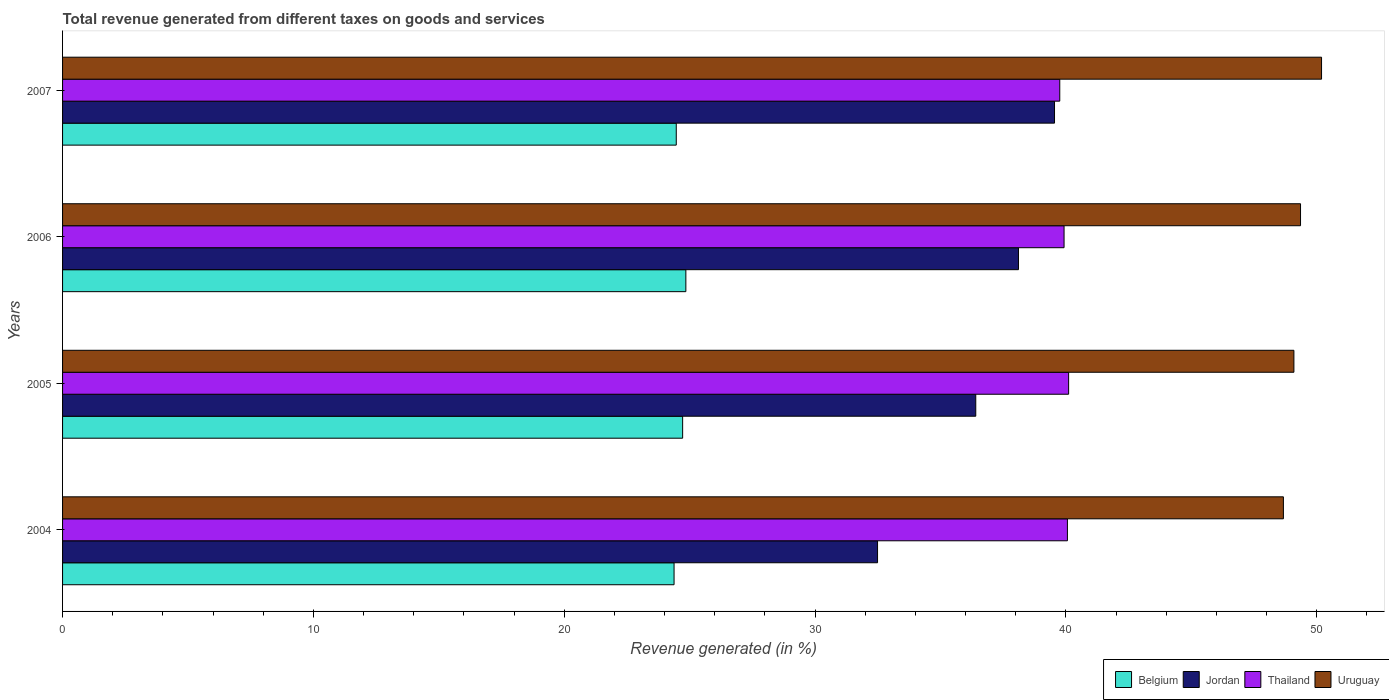How many different coloured bars are there?
Keep it short and to the point. 4. What is the label of the 2nd group of bars from the top?
Your answer should be compact. 2006. What is the total revenue generated in Uruguay in 2005?
Offer a terse response. 49.09. Across all years, what is the maximum total revenue generated in Belgium?
Provide a succinct answer. 24.85. Across all years, what is the minimum total revenue generated in Belgium?
Make the answer very short. 24.38. What is the total total revenue generated in Jordan in the graph?
Provide a succinct answer. 146.55. What is the difference between the total revenue generated in Uruguay in 2005 and that in 2006?
Your answer should be compact. -0.26. What is the difference between the total revenue generated in Uruguay in 2006 and the total revenue generated in Jordan in 2005?
Offer a very short reply. 12.95. What is the average total revenue generated in Belgium per year?
Your answer should be very brief. 24.6. In the year 2006, what is the difference between the total revenue generated in Belgium and total revenue generated in Jordan?
Give a very brief answer. -13.26. What is the ratio of the total revenue generated in Thailand in 2004 to that in 2006?
Your answer should be compact. 1. What is the difference between the highest and the second highest total revenue generated in Thailand?
Offer a very short reply. 0.05. What is the difference between the highest and the lowest total revenue generated in Thailand?
Offer a very short reply. 0.35. Is the sum of the total revenue generated in Thailand in 2006 and 2007 greater than the maximum total revenue generated in Belgium across all years?
Make the answer very short. Yes. Is it the case that in every year, the sum of the total revenue generated in Uruguay and total revenue generated in Belgium is greater than the sum of total revenue generated in Thailand and total revenue generated in Jordan?
Your response must be concise. Yes. What does the 1st bar from the top in 2004 represents?
Your answer should be very brief. Uruguay. What does the 3rd bar from the bottom in 2007 represents?
Give a very brief answer. Thailand. Are all the bars in the graph horizontal?
Provide a succinct answer. Yes. What is the difference between two consecutive major ticks on the X-axis?
Your answer should be compact. 10. Does the graph contain grids?
Provide a succinct answer. No. How many legend labels are there?
Your answer should be very brief. 4. How are the legend labels stacked?
Ensure brevity in your answer.  Horizontal. What is the title of the graph?
Offer a very short reply. Total revenue generated from different taxes on goods and services. What is the label or title of the X-axis?
Your response must be concise. Revenue generated (in %). What is the label or title of the Y-axis?
Offer a very short reply. Years. What is the Revenue generated (in %) of Belgium in 2004?
Offer a very short reply. 24.38. What is the Revenue generated (in %) in Jordan in 2004?
Ensure brevity in your answer.  32.49. What is the Revenue generated (in %) in Thailand in 2004?
Ensure brevity in your answer.  40.06. What is the Revenue generated (in %) in Uruguay in 2004?
Your response must be concise. 48.67. What is the Revenue generated (in %) in Belgium in 2005?
Keep it short and to the point. 24.72. What is the Revenue generated (in %) of Jordan in 2005?
Offer a terse response. 36.41. What is the Revenue generated (in %) in Thailand in 2005?
Offer a terse response. 40.11. What is the Revenue generated (in %) in Uruguay in 2005?
Provide a short and direct response. 49.09. What is the Revenue generated (in %) of Belgium in 2006?
Give a very brief answer. 24.85. What is the Revenue generated (in %) of Jordan in 2006?
Your answer should be compact. 38.11. What is the Revenue generated (in %) of Thailand in 2006?
Keep it short and to the point. 39.93. What is the Revenue generated (in %) in Uruguay in 2006?
Ensure brevity in your answer.  49.35. What is the Revenue generated (in %) of Belgium in 2007?
Your response must be concise. 24.47. What is the Revenue generated (in %) in Jordan in 2007?
Your answer should be compact. 39.55. What is the Revenue generated (in %) of Thailand in 2007?
Keep it short and to the point. 39.76. What is the Revenue generated (in %) in Uruguay in 2007?
Give a very brief answer. 50.19. Across all years, what is the maximum Revenue generated (in %) in Belgium?
Your answer should be very brief. 24.85. Across all years, what is the maximum Revenue generated (in %) in Jordan?
Offer a terse response. 39.55. Across all years, what is the maximum Revenue generated (in %) of Thailand?
Offer a very short reply. 40.11. Across all years, what is the maximum Revenue generated (in %) of Uruguay?
Ensure brevity in your answer.  50.19. Across all years, what is the minimum Revenue generated (in %) in Belgium?
Offer a terse response. 24.38. Across all years, what is the minimum Revenue generated (in %) in Jordan?
Offer a terse response. 32.49. Across all years, what is the minimum Revenue generated (in %) in Thailand?
Offer a very short reply. 39.76. Across all years, what is the minimum Revenue generated (in %) in Uruguay?
Your answer should be compact. 48.67. What is the total Revenue generated (in %) in Belgium in the graph?
Your answer should be compact. 98.42. What is the total Revenue generated (in %) of Jordan in the graph?
Your response must be concise. 146.55. What is the total Revenue generated (in %) of Thailand in the graph?
Provide a short and direct response. 159.85. What is the total Revenue generated (in %) of Uruguay in the graph?
Make the answer very short. 197.31. What is the difference between the Revenue generated (in %) of Belgium in 2004 and that in 2005?
Your answer should be very brief. -0.34. What is the difference between the Revenue generated (in %) of Jordan in 2004 and that in 2005?
Your answer should be compact. -3.92. What is the difference between the Revenue generated (in %) of Thailand in 2004 and that in 2005?
Keep it short and to the point. -0.05. What is the difference between the Revenue generated (in %) in Uruguay in 2004 and that in 2005?
Offer a terse response. -0.42. What is the difference between the Revenue generated (in %) of Belgium in 2004 and that in 2006?
Offer a terse response. -0.47. What is the difference between the Revenue generated (in %) of Jordan in 2004 and that in 2006?
Your answer should be very brief. -5.62. What is the difference between the Revenue generated (in %) of Thailand in 2004 and that in 2006?
Your answer should be compact. 0.13. What is the difference between the Revenue generated (in %) of Uruguay in 2004 and that in 2006?
Give a very brief answer. -0.68. What is the difference between the Revenue generated (in %) of Belgium in 2004 and that in 2007?
Give a very brief answer. -0.09. What is the difference between the Revenue generated (in %) in Jordan in 2004 and that in 2007?
Offer a terse response. -7.06. What is the difference between the Revenue generated (in %) of Thailand in 2004 and that in 2007?
Your answer should be very brief. 0.3. What is the difference between the Revenue generated (in %) of Uruguay in 2004 and that in 2007?
Make the answer very short. -1.52. What is the difference between the Revenue generated (in %) of Belgium in 2005 and that in 2006?
Provide a short and direct response. -0.13. What is the difference between the Revenue generated (in %) in Jordan in 2005 and that in 2006?
Provide a succinct answer. -1.7. What is the difference between the Revenue generated (in %) in Thailand in 2005 and that in 2006?
Ensure brevity in your answer.  0.18. What is the difference between the Revenue generated (in %) of Uruguay in 2005 and that in 2006?
Offer a terse response. -0.26. What is the difference between the Revenue generated (in %) in Belgium in 2005 and that in 2007?
Offer a very short reply. 0.25. What is the difference between the Revenue generated (in %) of Jordan in 2005 and that in 2007?
Your response must be concise. -3.14. What is the difference between the Revenue generated (in %) in Thailand in 2005 and that in 2007?
Your answer should be very brief. 0.35. What is the difference between the Revenue generated (in %) in Uruguay in 2005 and that in 2007?
Ensure brevity in your answer.  -1.1. What is the difference between the Revenue generated (in %) in Belgium in 2006 and that in 2007?
Your answer should be very brief. 0.38. What is the difference between the Revenue generated (in %) of Jordan in 2006 and that in 2007?
Offer a very short reply. -1.44. What is the difference between the Revenue generated (in %) in Thailand in 2006 and that in 2007?
Your answer should be compact. 0.17. What is the difference between the Revenue generated (in %) in Uruguay in 2006 and that in 2007?
Give a very brief answer. -0.84. What is the difference between the Revenue generated (in %) in Belgium in 2004 and the Revenue generated (in %) in Jordan in 2005?
Ensure brevity in your answer.  -12.03. What is the difference between the Revenue generated (in %) of Belgium in 2004 and the Revenue generated (in %) of Thailand in 2005?
Offer a very short reply. -15.73. What is the difference between the Revenue generated (in %) of Belgium in 2004 and the Revenue generated (in %) of Uruguay in 2005?
Ensure brevity in your answer.  -24.71. What is the difference between the Revenue generated (in %) in Jordan in 2004 and the Revenue generated (in %) in Thailand in 2005?
Provide a succinct answer. -7.62. What is the difference between the Revenue generated (in %) of Jordan in 2004 and the Revenue generated (in %) of Uruguay in 2005?
Your answer should be very brief. -16.6. What is the difference between the Revenue generated (in %) of Thailand in 2004 and the Revenue generated (in %) of Uruguay in 2005?
Provide a short and direct response. -9.03. What is the difference between the Revenue generated (in %) in Belgium in 2004 and the Revenue generated (in %) in Jordan in 2006?
Ensure brevity in your answer.  -13.73. What is the difference between the Revenue generated (in %) in Belgium in 2004 and the Revenue generated (in %) in Thailand in 2006?
Give a very brief answer. -15.55. What is the difference between the Revenue generated (in %) of Belgium in 2004 and the Revenue generated (in %) of Uruguay in 2006?
Provide a succinct answer. -24.98. What is the difference between the Revenue generated (in %) of Jordan in 2004 and the Revenue generated (in %) of Thailand in 2006?
Keep it short and to the point. -7.44. What is the difference between the Revenue generated (in %) of Jordan in 2004 and the Revenue generated (in %) of Uruguay in 2006?
Keep it short and to the point. -16.86. What is the difference between the Revenue generated (in %) of Thailand in 2004 and the Revenue generated (in %) of Uruguay in 2006?
Offer a terse response. -9.29. What is the difference between the Revenue generated (in %) in Belgium in 2004 and the Revenue generated (in %) in Jordan in 2007?
Give a very brief answer. -15.17. What is the difference between the Revenue generated (in %) in Belgium in 2004 and the Revenue generated (in %) in Thailand in 2007?
Provide a succinct answer. -15.38. What is the difference between the Revenue generated (in %) of Belgium in 2004 and the Revenue generated (in %) of Uruguay in 2007?
Provide a short and direct response. -25.81. What is the difference between the Revenue generated (in %) of Jordan in 2004 and the Revenue generated (in %) of Thailand in 2007?
Offer a terse response. -7.26. What is the difference between the Revenue generated (in %) in Jordan in 2004 and the Revenue generated (in %) in Uruguay in 2007?
Offer a terse response. -17.7. What is the difference between the Revenue generated (in %) of Thailand in 2004 and the Revenue generated (in %) of Uruguay in 2007?
Offer a very short reply. -10.13. What is the difference between the Revenue generated (in %) in Belgium in 2005 and the Revenue generated (in %) in Jordan in 2006?
Your answer should be very brief. -13.39. What is the difference between the Revenue generated (in %) in Belgium in 2005 and the Revenue generated (in %) in Thailand in 2006?
Your answer should be compact. -15.21. What is the difference between the Revenue generated (in %) of Belgium in 2005 and the Revenue generated (in %) of Uruguay in 2006?
Offer a terse response. -24.63. What is the difference between the Revenue generated (in %) in Jordan in 2005 and the Revenue generated (in %) in Thailand in 2006?
Provide a short and direct response. -3.52. What is the difference between the Revenue generated (in %) of Jordan in 2005 and the Revenue generated (in %) of Uruguay in 2006?
Your answer should be compact. -12.95. What is the difference between the Revenue generated (in %) in Thailand in 2005 and the Revenue generated (in %) in Uruguay in 2006?
Offer a terse response. -9.25. What is the difference between the Revenue generated (in %) of Belgium in 2005 and the Revenue generated (in %) of Jordan in 2007?
Make the answer very short. -14.83. What is the difference between the Revenue generated (in %) in Belgium in 2005 and the Revenue generated (in %) in Thailand in 2007?
Offer a terse response. -15.04. What is the difference between the Revenue generated (in %) of Belgium in 2005 and the Revenue generated (in %) of Uruguay in 2007?
Your response must be concise. -25.47. What is the difference between the Revenue generated (in %) in Jordan in 2005 and the Revenue generated (in %) in Thailand in 2007?
Keep it short and to the point. -3.35. What is the difference between the Revenue generated (in %) in Jordan in 2005 and the Revenue generated (in %) in Uruguay in 2007?
Your response must be concise. -13.79. What is the difference between the Revenue generated (in %) of Thailand in 2005 and the Revenue generated (in %) of Uruguay in 2007?
Your answer should be compact. -10.08. What is the difference between the Revenue generated (in %) of Belgium in 2006 and the Revenue generated (in %) of Jordan in 2007?
Give a very brief answer. -14.7. What is the difference between the Revenue generated (in %) in Belgium in 2006 and the Revenue generated (in %) in Thailand in 2007?
Provide a short and direct response. -14.91. What is the difference between the Revenue generated (in %) of Belgium in 2006 and the Revenue generated (in %) of Uruguay in 2007?
Offer a terse response. -25.34. What is the difference between the Revenue generated (in %) in Jordan in 2006 and the Revenue generated (in %) in Thailand in 2007?
Ensure brevity in your answer.  -1.65. What is the difference between the Revenue generated (in %) in Jordan in 2006 and the Revenue generated (in %) in Uruguay in 2007?
Give a very brief answer. -12.08. What is the difference between the Revenue generated (in %) in Thailand in 2006 and the Revenue generated (in %) in Uruguay in 2007?
Provide a succinct answer. -10.27. What is the average Revenue generated (in %) of Belgium per year?
Your answer should be very brief. 24.6. What is the average Revenue generated (in %) of Jordan per year?
Offer a terse response. 36.64. What is the average Revenue generated (in %) in Thailand per year?
Provide a succinct answer. 39.96. What is the average Revenue generated (in %) of Uruguay per year?
Offer a very short reply. 49.33. In the year 2004, what is the difference between the Revenue generated (in %) of Belgium and Revenue generated (in %) of Jordan?
Make the answer very short. -8.11. In the year 2004, what is the difference between the Revenue generated (in %) of Belgium and Revenue generated (in %) of Thailand?
Make the answer very short. -15.68. In the year 2004, what is the difference between the Revenue generated (in %) of Belgium and Revenue generated (in %) of Uruguay?
Keep it short and to the point. -24.29. In the year 2004, what is the difference between the Revenue generated (in %) in Jordan and Revenue generated (in %) in Thailand?
Provide a short and direct response. -7.57. In the year 2004, what is the difference between the Revenue generated (in %) in Jordan and Revenue generated (in %) in Uruguay?
Ensure brevity in your answer.  -16.18. In the year 2004, what is the difference between the Revenue generated (in %) in Thailand and Revenue generated (in %) in Uruguay?
Provide a succinct answer. -8.61. In the year 2005, what is the difference between the Revenue generated (in %) of Belgium and Revenue generated (in %) of Jordan?
Make the answer very short. -11.69. In the year 2005, what is the difference between the Revenue generated (in %) in Belgium and Revenue generated (in %) in Thailand?
Your answer should be very brief. -15.39. In the year 2005, what is the difference between the Revenue generated (in %) in Belgium and Revenue generated (in %) in Uruguay?
Keep it short and to the point. -24.37. In the year 2005, what is the difference between the Revenue generated (in %) of Jordan and Revenue generated (in %) of Thailand?
Offer a terse response. -3.7. In the year 2005, what is the difference between the Revenue generated (in %) in Jordan and Revenue generated (in %) in Uruguay?
Offer a very short reply. -12.68. In the year 2005, what is the difference between the Revenue generated (in %) in Thailand and Revenue generated (in %) in Uruguay?
Your answer should be compact. -8.98. In the year 2006, what is the difference between the Revenue generated (in %) of Belgium and Revenue generated (in %) of Jordan?
Ensure brevity in your answer.  -13.26. In the year 2006, what is the difference between the Revenue generated (in %) of Belgium and Revenue generated (in %) of Thailand?
Your response must be concise. -15.08. In the year 2006, what is the difference between the Revenue generated (in %) of Belgium and Revenue generated (in %) of Uruguay?
Provide a short and direct response. -24.5. In the year 2006, what is the difference between the Revenue generated (in %) in Jordan and Revenue generated (in %) in Thailand?
Your answer should be compact. -1.82. In the year 2006, what is the difference between the Revenue generated (in %) in Jordan and Revenue generated (in %) in Uruguay?
Provide a short and direct response. -11.25. In the year 2006, what is the difference between the Revenue generated (in %) in Thailand and Revenue generated (in %) in Uruguay?
Your answer should be compact. -9.43. In the year 2007, what is the difference between the Revenue generated (in %) in Belgium and Revenue generated (in %) in Jordan?
Keep it short and to the point. -15.08. In the year 2007, what is the difference between the Revenue generated (in %) of Belgium and Revenue generated (in %) of Thailand?
Your answer should be compact. -15.29. In the year 2007, what is the difference between the Revenue generated (in %) in Belgium and Revenue generated (in %) in Uruguay?
Ensure brevity in your answer.  -25.73. In the year 2007, what is the difference between the Revenue generated (in %) in Jordan and Revenue generated (in %) in Thailand?
Offer a very short reply. -0.21. In the year 2007, what is the difference between the Revenue generated (in %) in Jordan and Revenue generated (in %) in Uruguay?
Your answer should be compact. -10.65. In the year 2007, what is the difference between the Revenue generated (in %) of Thailand and Revenue generated (in %) of Uruguay?
Provide a short and direct response. -10.44. What is the ratio of the Revenue generated (in %) of Belgium in 2004 to that in 2005?
Keep it short and to the point. 0.99. What is the ratio of the Revenue generated (in %) of Jordan in 2004 to that in 2005?
Your response must be concise. 0.89. What is the ratio of the Revenue generated (in %) of Thailand in 2004 to that in 2005?
Make the answer very short. 1. What is the ratio of the Revenue generated (in %) in Uruguay in 2004 to that in 2005?
Your answer should be compact. 0.99. What is the ratio of the Revenue generated (in %) of Belgium in 2004 to that in 2006?
Give a very brief answer. 0.98. What is the ratio of the Revenue generated (in %) in Jordan in 2004 to that in 2006?
Keep it short and to the point. 0.85. What is the ratio of the Revenue generated (in %) in Thailand in 2004 to that in 2006?
Your answer should be very brief. 1. What is the ratio of the Revenue generated (in %) of Uruguay in 2004 to that in 2006?
Your answer should be very brief. 0.99. What is the ratio of the Revenue generated (in %) of Belgium in 2004 to that in 2007?
Make the answer very short. 1. What is the ratio of the Revenue generated (in %) in Jordan in 2004 to that in 2007?
Make the answer very short. 0.82. What is the ratio of the Revenue generated (in %) in Thailand in 2004 to that in 2007?
Your response must be concise. 1.01. What is the ratio of the Revenue generated (in %) of Uruguay in 2004 to that in 2007?
Your response must be concise. 0.97. What is the ratio of the Revenue generated (in %) of Belgium in 2005 to that in 2006?
Provide a succinct answer. 0.99. What is the ratio of the Revenue generated (in %) of Jordan in 2005 to that in 2006?
Offer a very short reply. 0.96. What is the ratio of the Revenue generated (in %) of Thailand in 2005 to that in 2006?
Your answer should be very brief. 1. What is the ratio of the Revenue generated (in %) of Belgium in 2005 to that in 2007?
Offer a very short reply. 1.01. What is the ratio of the Revenue generated (in %) of Jordan in 2005 to that in 2007?
Your answer should be compact. 0.92. What is the ratio of the Revenue generated (in %) in Thailand in 2005 to that in 2007?
Give a very brief answer. 1.01. What is the ratio of the Revenue generated (in %) in Uruguay in 2005 to that in 2007?
Ensure brevity in your answer.  0.98. What is the ratio of the Revenue generated (in %) in Belgium in 2006 to that in 2007?
Your answer should be compact. 1.02. What is the ratio of the Revenue generated (in %) in Jordan in 2006 to that in 2007?
Your answer should be very brief. 0.96. What is the ratio of the Revenue generated (in %) in Thailand in 2006 to that in 2007?
Ensure brevity in your answer.  1. What is the ratio of the Revenue generated (in %) in Uruguay in 2006 to that in 2007?
Your answer should be very brief. 0.98. What is the difference between the highest and the second highest Revenue generated (in %) of Belgium?
Your answer should be very brief. 0.13. What is the difference between the highest and the second highest Revenue generated (in %) in Jordan?
Offer a very short reply. 1.44. What is the difference between the highest and the second highest Revenue generated (in %) of Thailand?
Make the answer very short. 0.05. What is the difference between the highest and the second highest Revenue generated (in %) in Uruguay?
Provide a short and direct response. 0.84. What is the difference between the highest and the lowest Revenue generated (in %) of Belgium?
Give a very brief answer. 0.47. What is the difference between the highest and the lowest Revenue generated (in %) of Jordan?
Your response must be concise. 7.06. What is the difference between the highest and the lowest Revenue generated (in %) in Thailand?
Offer a terse response. 0.35. What is the difference between the highest and the lowest Revenue generated (in %) in Uruguay?
Provide a succinct answer. 1.52. 